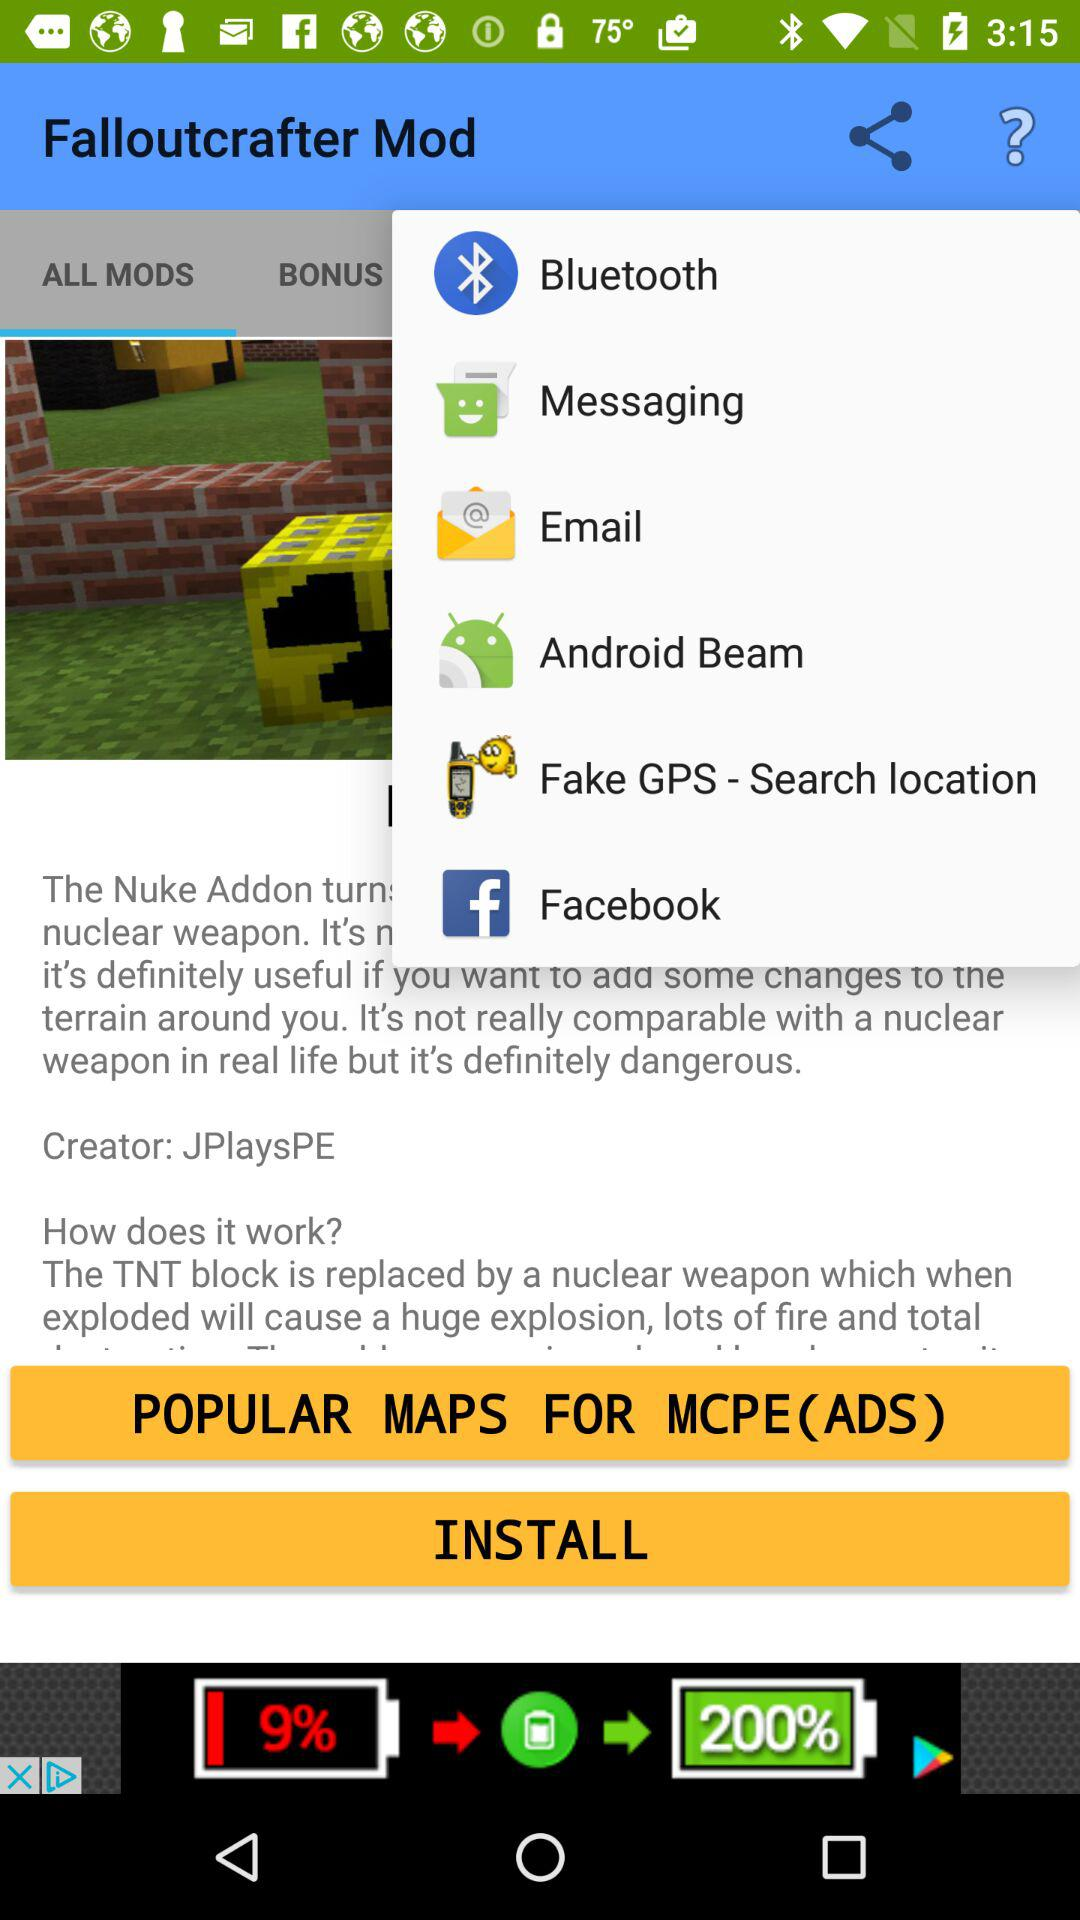What's the creator name? The creator name is "JPlaysPE". 